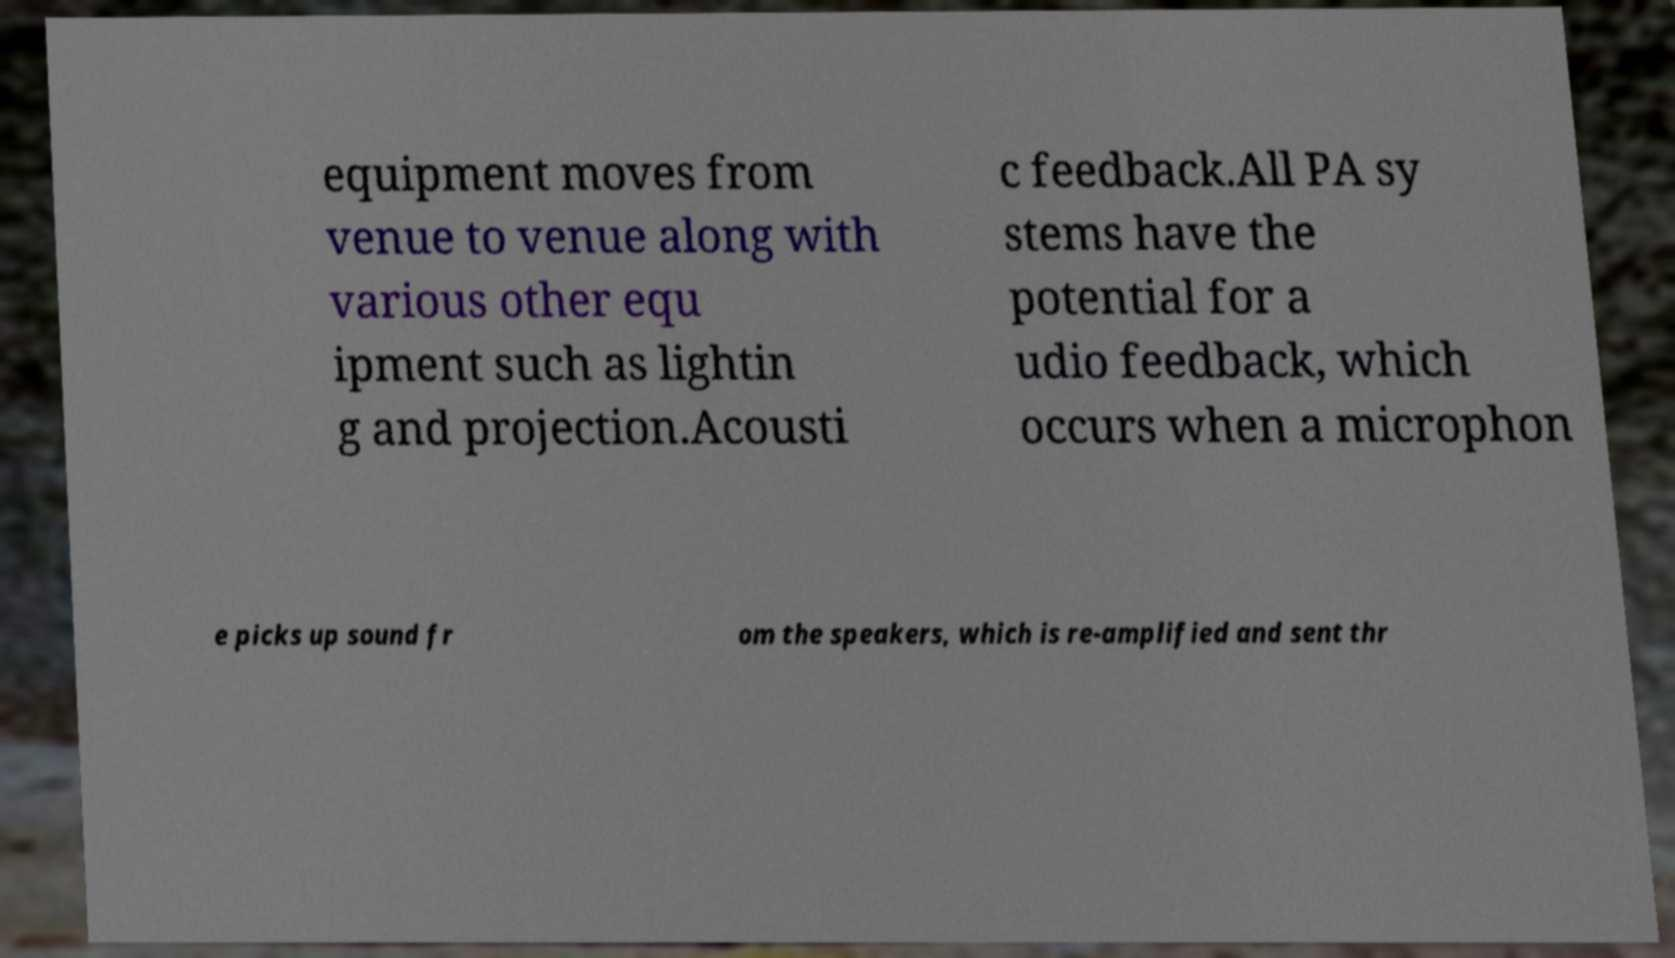Could you assist in decoding the text presented in this image and type it out clearly? equipment moves from venue to venue along with various other equ ipment such as lightin g and projection.Acousti c feedback.All PA sy stems have the potential for a udio feedback, which occurs when a microphon e picks up sound fr om the speakers, which is re-amplified and sent thr 